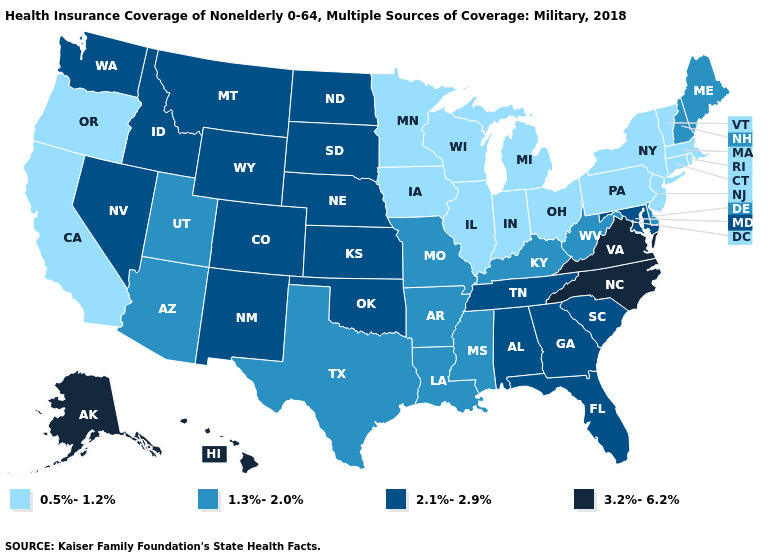What is the value of New Hampshire?
Short answer required. 1.3%-2.0%. Among the states that border Michigan , which have the lowest value?
Write a very short answer. Indiana, Ohio, Wisconsin. Name the states that have a value in the range 1.3%-2.0%?
Write a very short answer. Arizona, Arkansas, Delaware, Kentucky, Louisiana, Maine, Mississippi, Missouri, New Hampshire, Texas, Utah, West Virginia. Name the states that have a value in the range 0.5%-1.2%?
Give a very brief answer. California, Connecticut, Illinois, Indiana, Iowa, Massachusetts, Michigan, Minnesota, New Jersey, New York, Ohio, Oregon, Pennsylvania, Rhode Island, Vermont, Wisconsin. Does Connecticut have the lowest value in the USA?
Be succinct. Yes. What is the value of California?
Quick response, please. 0.5%-1.2%. Does the first symbol in the legend represent the smallest category?
Keep it brief. Yes. Does Kansas have the same value as Washington?
Quick response, please. Yes. Does Arkansas have the same value as Utah?
Give a very brief answer. Yes. Which states have the lowest value in the USA?
Be succinct. California, Connecticut, Illinois, Indiana, Iowa, Massachusetts, Michigan, Minnesota, New Jersey, New York, Ohio, Oregon, Pennsylvania, Rhode Island, Vermont, Wisconsin. Name the states that have a value in the range 0.5%-1.2%?
Concise answer only. California, Connecticut, Illinois, Indiana, Iowa, Massachusetts, Michigan, Minnesota, New Jersey, New York, Ohio, Oregon, Pennsylvania, Rhode Island, Vermont, Wisconsin. What is the highest value in the USA?
Concise answer only. 3.2%-6.2%. Name the states that have a value in the range 0.5%-1.2%?
Give a very brief answer. California, Connecticut, Illinois, Indiana, Iowa, Massachusetts, Michigan, Minnesota, New Jersey, New York, Ohio, Oregon, Pennsylvania, Rhode Island, Vermont, Wisconsin. What is the value of Wisconsin?
Answer briefly. 0.5%-1.2%. 